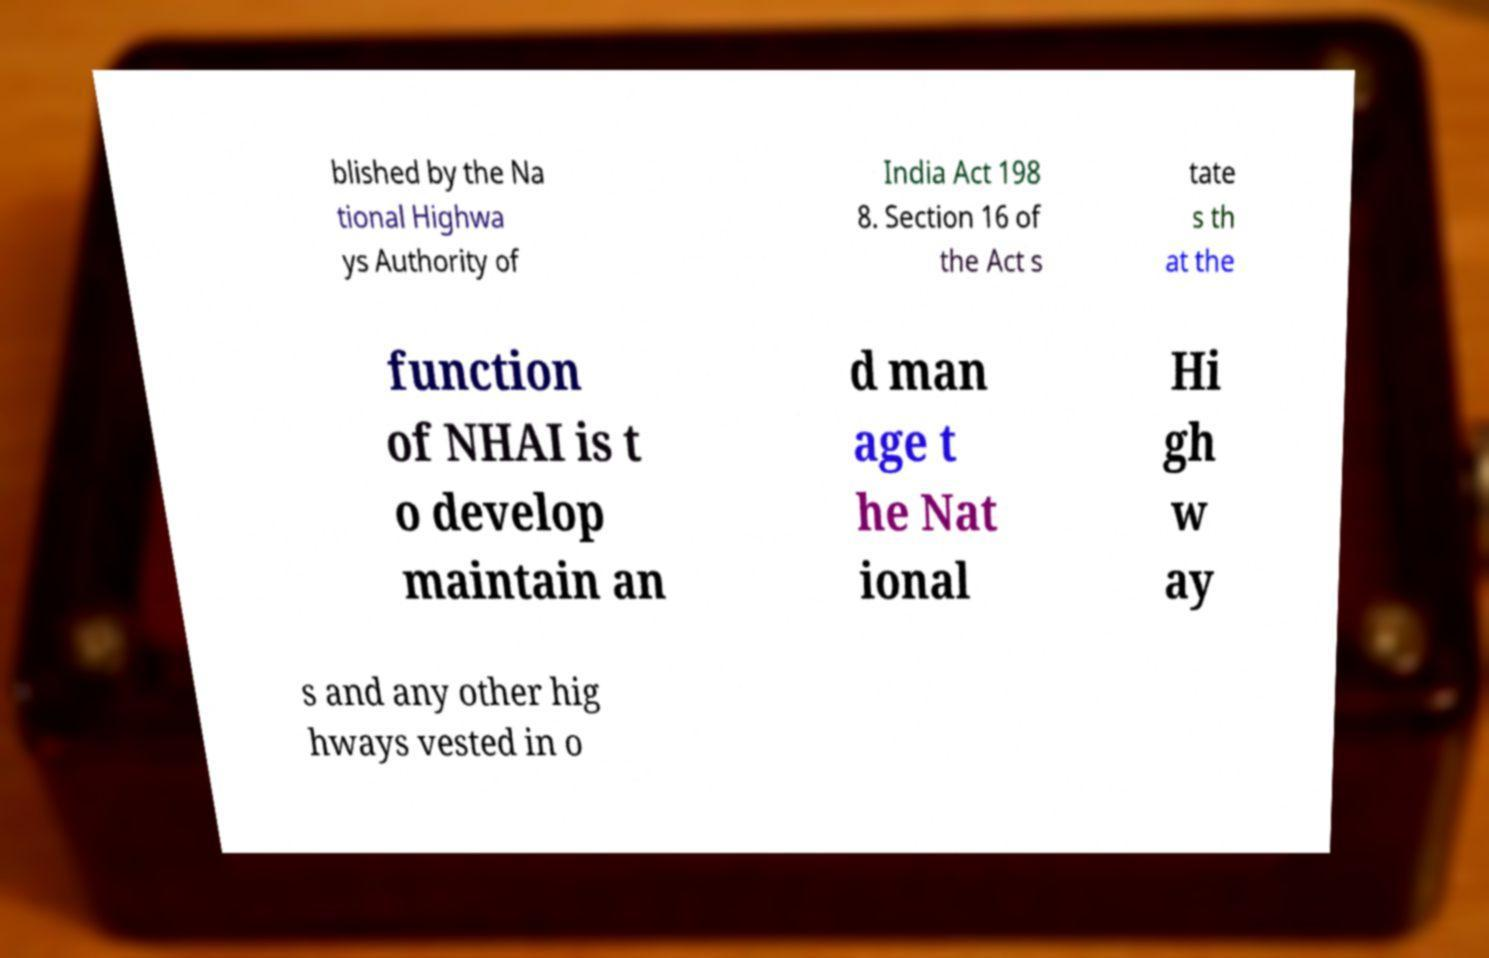Please read and relay the text visible in this image. What does it say? blished by the Na tional Highwa ys Authority of India Act 198 8. Section 16 of the Act s tate s th at the function of NHAI is t o develop maintain an d man age t he Nat ional Hi gh w ay s and any other hig hways vested in o 